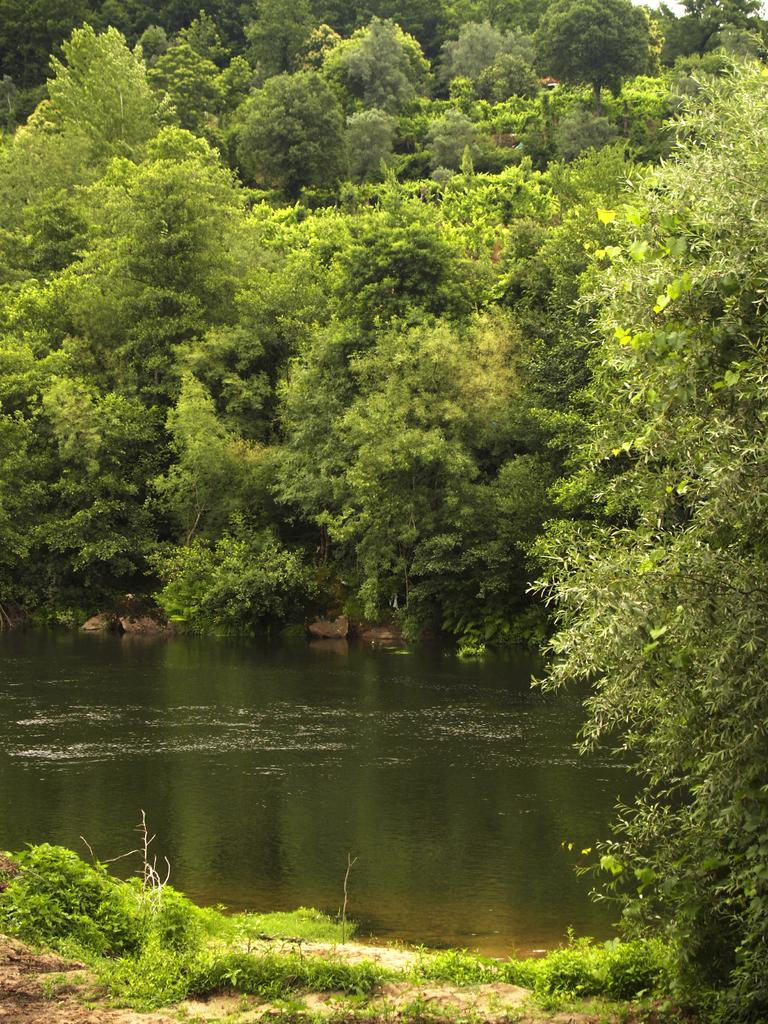What is located on the right side of the image? There is a tree on the ground on the right side of the image. What can be seen on the tree? There are plants on the tree. What type of vegetation is on the ground? There is grass on the ground. What is visible in the background of the image? There is water, likely a river, and trees and plants in the background of the image. What type of pancake is being served on the tree in the image? There is no pancake present in the image; it features a tree with plants on it. What stage of development is the tree in the image? The stage of development of the tree cannot be determined from the image alone. 